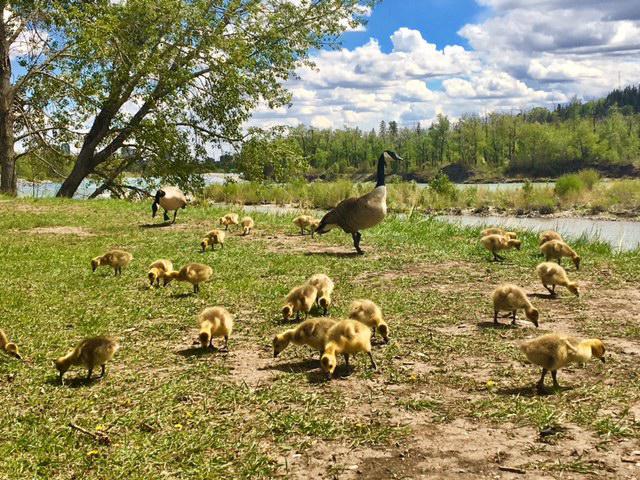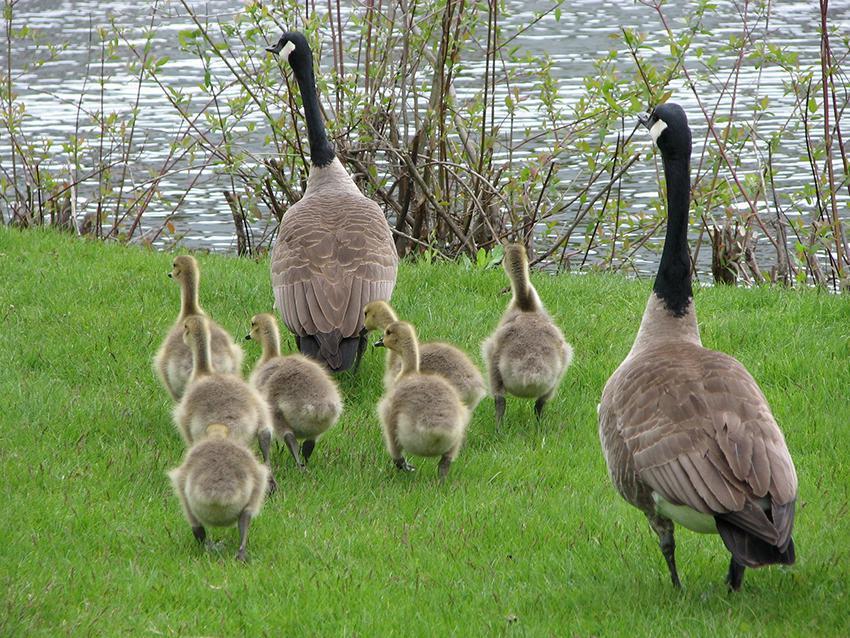The first image is the image on the left, the second image is the image on the right. Examine the images to the left and right. Is the description "The only living creatures in the image on the left are either adult or juvenile Canadian geese, too many to count." accurate? Answer yes or no. Yes. The first image is the image on the left, the second image is the image on the right. Given the left and right images, does the statement "There are multiple birds walking and grazing on patchy grass with dirt showing." hold true? Answer yes or no. Yes. 